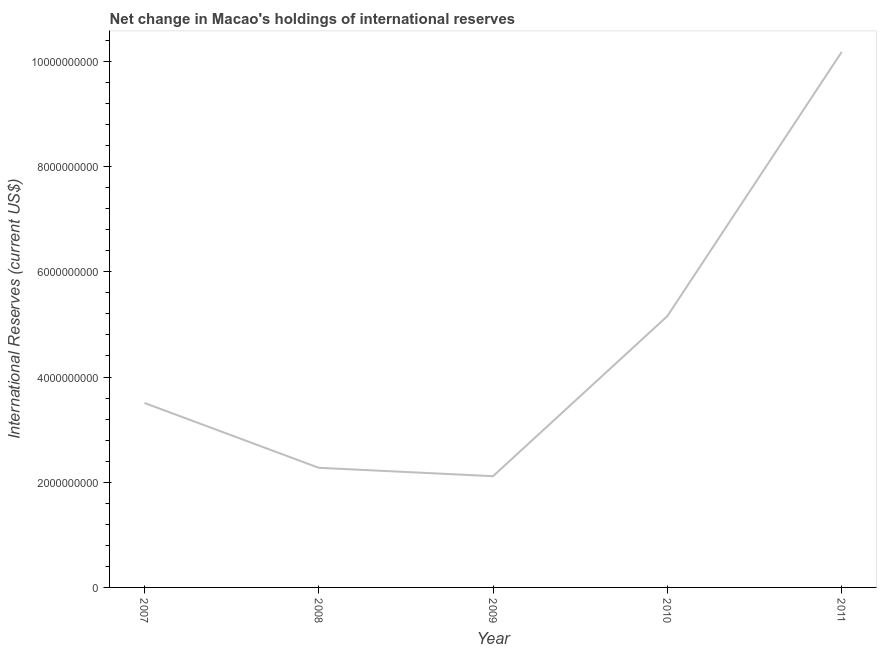What is the reserves and related items in 2010?
Offer a terse response. 5.16e+09. Across all years, what is the maximum reserves and related items?
Make the answer very short. 1.02e+1. Across all years, what is the minimum reserves and related items?
Your answer should be compact. 2.11e+09. What is the sum of the reserves and related items?
Your answer should be compact. 2.32e+1. What is the difference between the reserves and related items in 2007 and 2008?
Make the answer very short. 1.23e+09. What is the average reserves and related items per year?
Your answer should be compact. 4.65e+09. What is the median reserves and related items?
Offer a very short reply. 3.51e+09. In how many years, is the reserves and related items greater than 2000000000 US$?
Keep it short and to the point. 5. What is the ratio of the reserves and related items in 2007 to that in 2011?
Give a very brief answer. 0.34. Is the difference between the reserves and related items in 2007 and 2010 greater than the difference between any two years?
Make the answer very short. No. What is the difference between the highest and the second highest reserves and related items?
Provide a short and direct response. 5.02e+09. What is the difference between the highest and the lowest reserves and related items?
Give a very brief answer. 8.06e+09. Does the reserves and related items monotonically increase over the years?
Provide a succinct answer. No. How many years are there in the graph?
Your answer should be very brief. 5. What is the title of the graph?
Ensure brevity in your answer.  Net change in Macao's holdings of international reserves. What is the label or title of the Y-axis?
Ensure brevity in your answer.  International Reserves (current US$). What is the International Reserves (current US$) in 2007?
Your response must be concise. 3.51e+09. What is the International Reserves (current US$) in 2008?
Keep it short and to the point. 2.27e+09. What is the International Reserves (current US$) in 2009?
Your answer should be compact. 2.11e+09. What is the International Reserves (current US$) in 2010?
Your response must be concise. 5.16e+09. What is the International Reserves (current US$) in 2011?
Your answer should be very brief. 1.02e+1. What is the difference between the International Reserves (current US$) in 2007 and 2008?
Give a very brief answer. 1.23e+09. What is the difference between the International Reserves (current US$) in 2007 and 2009?
Offer a terse response. 1.39e+09. What is the difference between the International Reserves (current US$) in 2007 and 2010?
Offer a terse response. -1.65e+09. What is the difference between the International Reserves (current US$) in 2007 and 2011?
Offer a terse response. -6.67e+09. What is the difference between the International Reserves (current US$) in 2008 and 2009?
Make the answer very short. 1.60e+08. What is the difference between the International Reserves (current US$) in 2008 and 2010?
Provide a short and direct response. -2.88e+09. What is the difference between the International Reserves (current US$) in 2008 and 2011?
Provide a succinct answer. -7.90e+09. What is the difference between the International Reserves (current US$) in 2009 and 2010?
Offer a terse response. -3.04e+09. What is the difference between the International Reserves (current US$) in 2009 and 2011?
Provide a succinct answer. -8.06e+09. What is the difference between the International Reserves (current US$) in 2010 and 2011?
Provide a short and direct response. -5.02e+09. What is the ratio of the International Reserves (current US$) in 2007 to that in 2008?
Give a very brief answer. 1.54. What is the ratio of the International Reserves (current US$) in 2007 to that in 2009?
Provide a short and direct response. 1.66. What is the ratio of the International Reserves (current US$) in 2007 to that in 2010?
Provide a short and direct response. 0.68. What is the ratio of the International Reserves (current US$) in 2007 to that in 2011?
Provide a short and direct response. 0.34. What is the ratio of the International Reserves (current US$) in 2008 to that in 2009?
Ensure brevity in your answer.  1.07. What is the ratio of the International Reserves (current US$) in 2008 to that in 2010?
Ensure brevity in your answer.  0.44. What is the ratio of the International Reserves (current US$) in 2008 to that in 2011?
Provide a succinct answer. 0.22. What is the ratio of the International Reserves (current US$) in 2009 to that in 2010?
Provide a short and direct response. 0.41. What is the ratio of the International Reserves (current US$) in 2009 to that in 2011?
Provide a short and direct response. 0.21. What is the ratio of the International Reserves (current US$) in 2010 to that in 2011?
Provide a short and direct response. 0.51. 